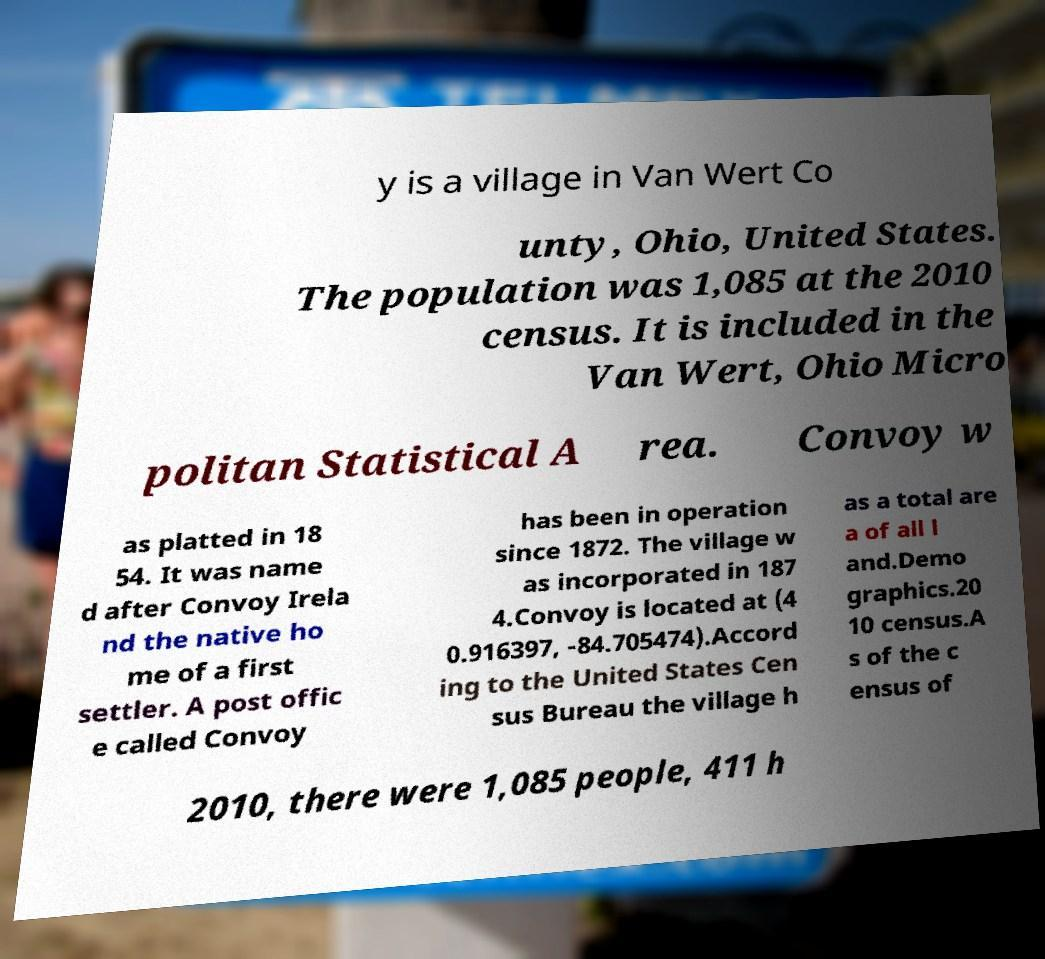For documentation purposes, I need the text within this image transcribed. Could you provide that? y is a village in Van Wert Co unty, Ohio, United States. The population was 1,085 at the 2010 census. It is included in the Van Wert, Ohio Micro politan Statistical A rea. Convoy w as platted in 18 54. It was name d after Convoy Irela nd the native ho me of a first settler. A post offic e called Convoy has been in operation since 1872. The village w as incorporated in 187 4.Convoy is located at (4 0.916397, -84.705474).Accord ing to the United States Cen sus Bureau the village h as a total are a of all l and.Demo graphics.20 10 census.A s of the c ensus of 2010, there were 1,085 people, 411 h 